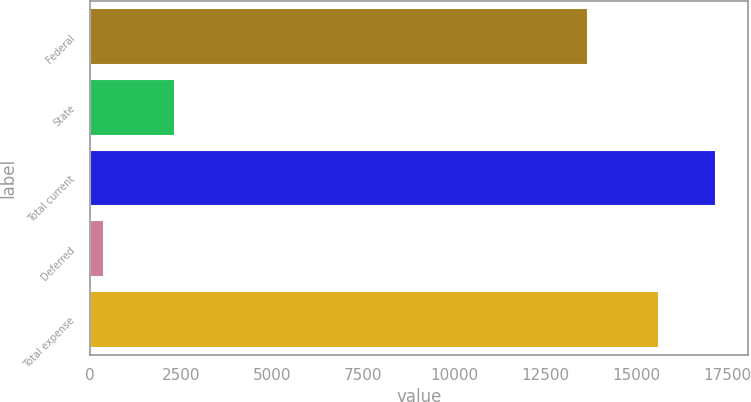<chart> <loc_0><loc_0><loc_500><loc_500><bar_chart><fcel>Federal<fcel>State<fcel>Total current<fcel>Deferred<fcel>Total expense<nl><fcel>13661<fcel>2338<fcel>17194.1<fcel>368<fcel>15631<nl></chart> 